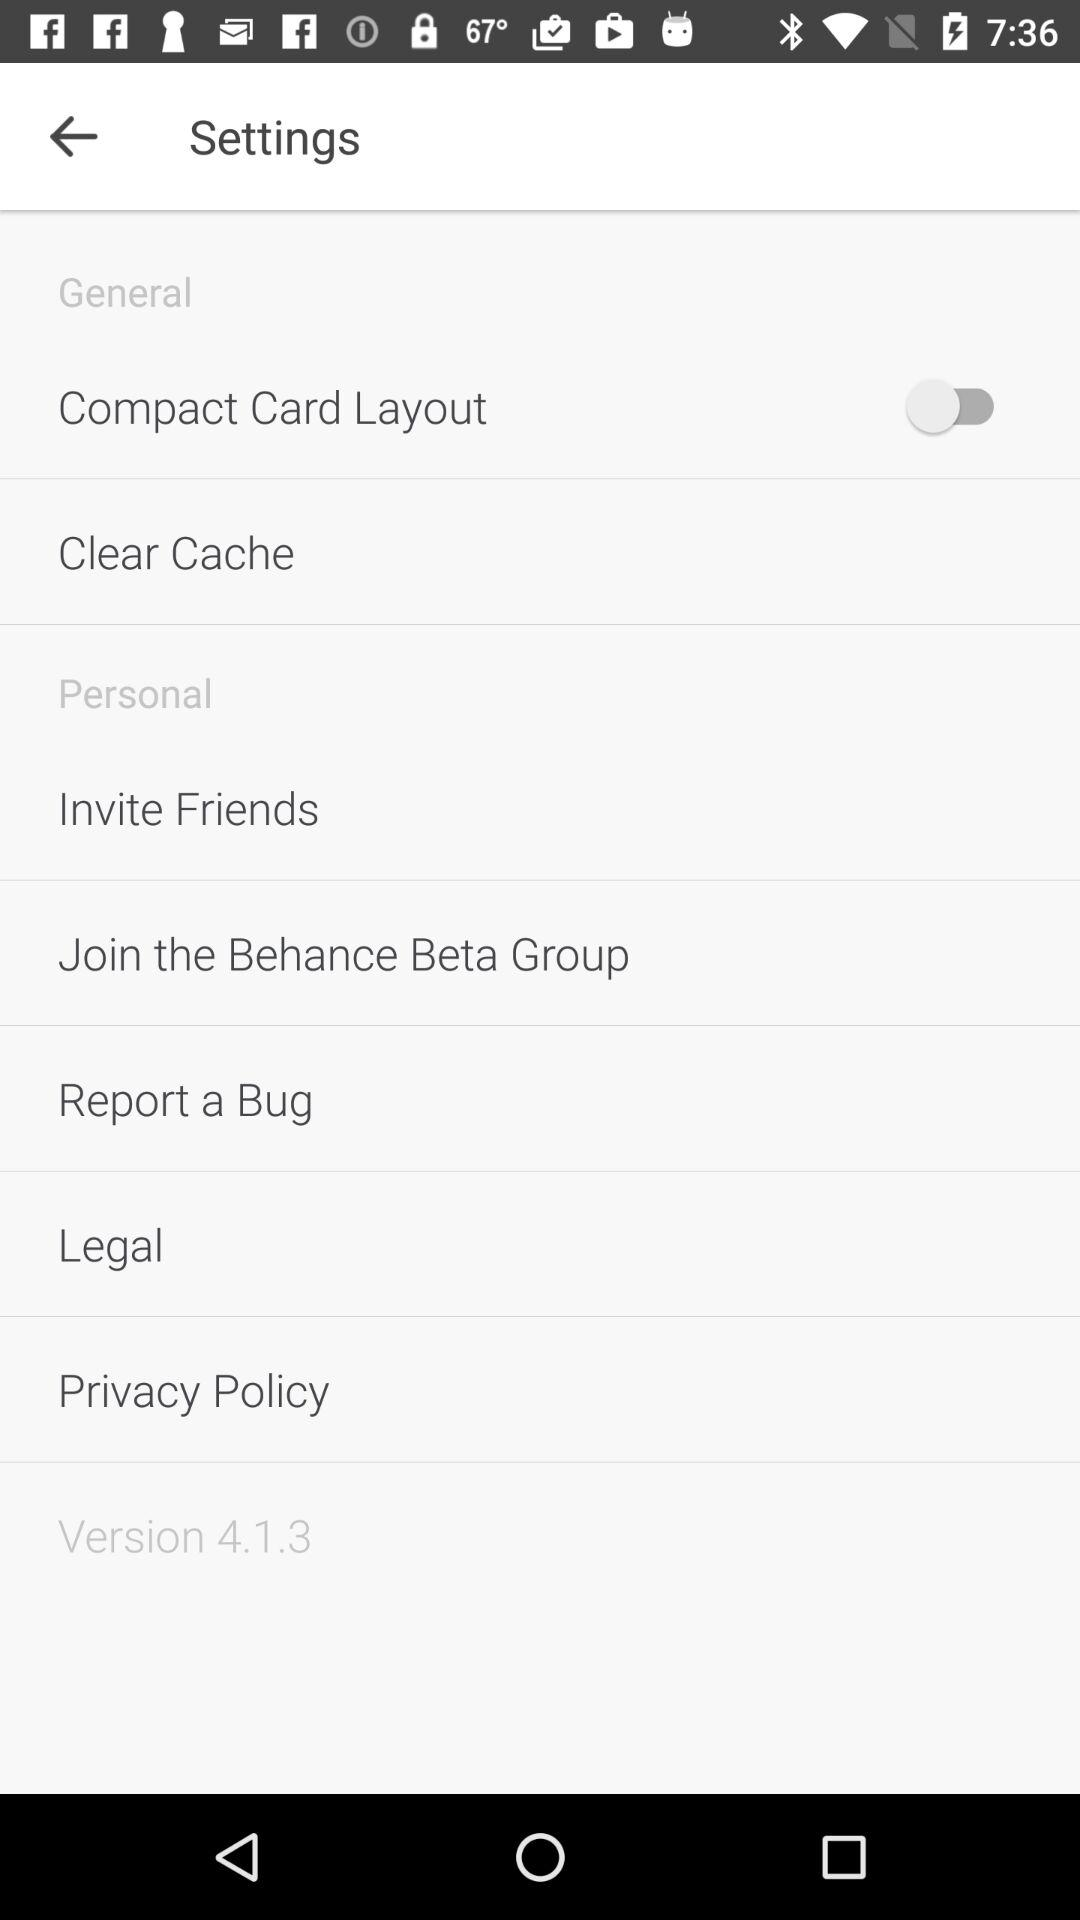What is the status of "Compact Card Layout"? The status of "Compact Card Layout" is "off". 